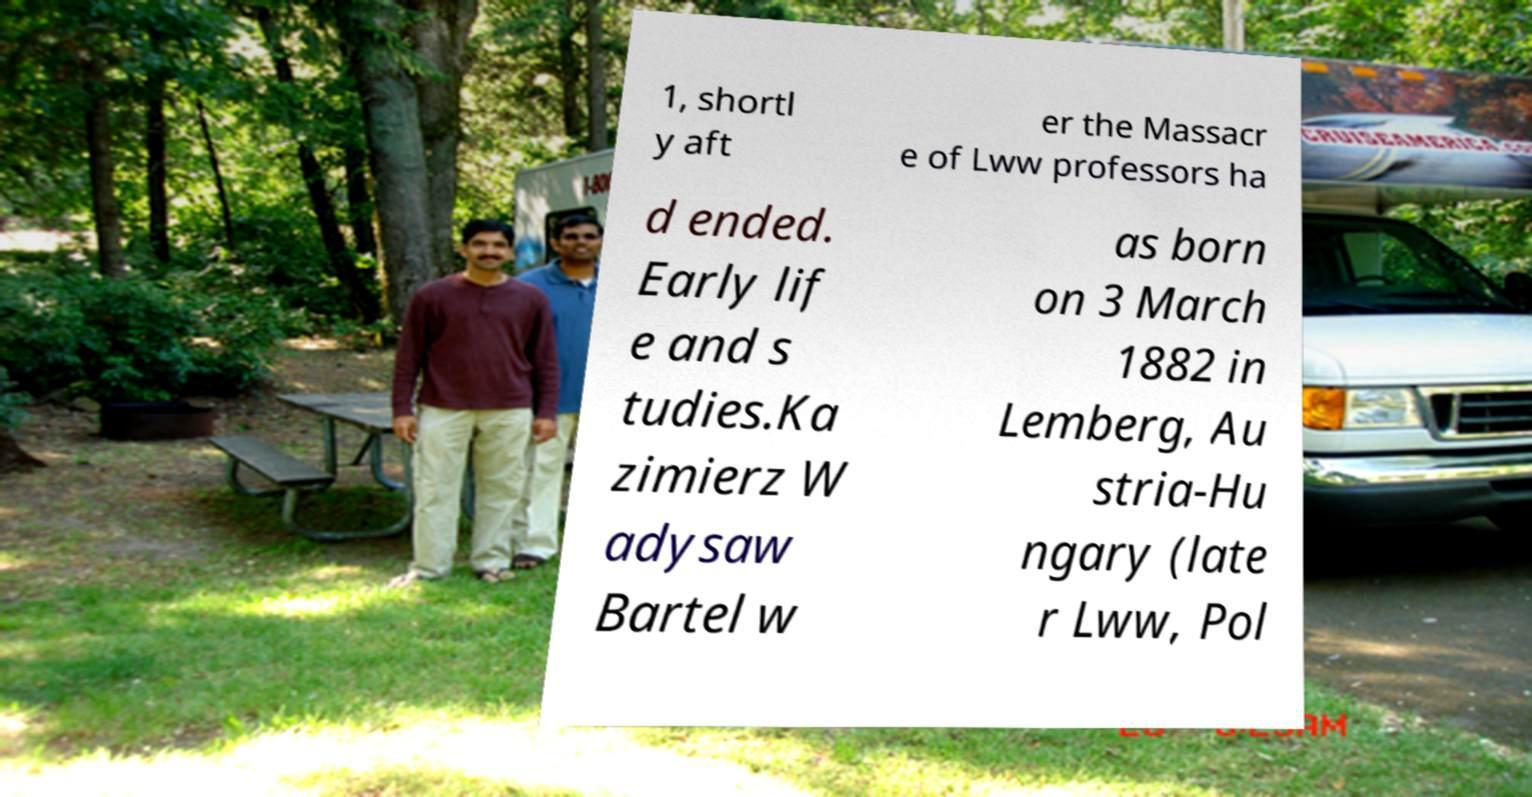Can you accurately transcribe the text from the provided image for me? 1, shortl y aft er the Massacr e of Lww professors ha d ended. Early lif e and s tudies.Ka zimierz W adysaw Bartel w as born on 3 March 1882 in Lemberg, Au stria-Hu ngary (late r Lww, Pol 